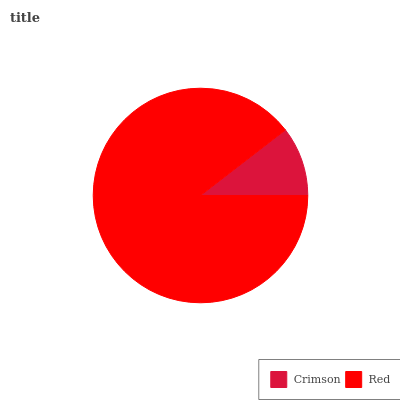Is Crimson the minimum?
Answer yes or no. Yes. Is Red the maximum?
Answer yes or no. Yes. Is Red the minimum?
Answer yes or no. No. Is Red greater than Crimson?
Answer yes or no. Yes. Is Crimson less than Red?
Answer yes or no. Yes. Is Crimson greater than Red?
Answer yes or no. No. Is Red less than Crimson?
Answer yes or no. No. Is Red the high median?
Answer yes or no. Yes. Is Crimson the low median?
Answer yes or no. Yes. Is Crimson the high median?
Answer yes or no. No. Is Red the low median?
Answer yes or no. No. 